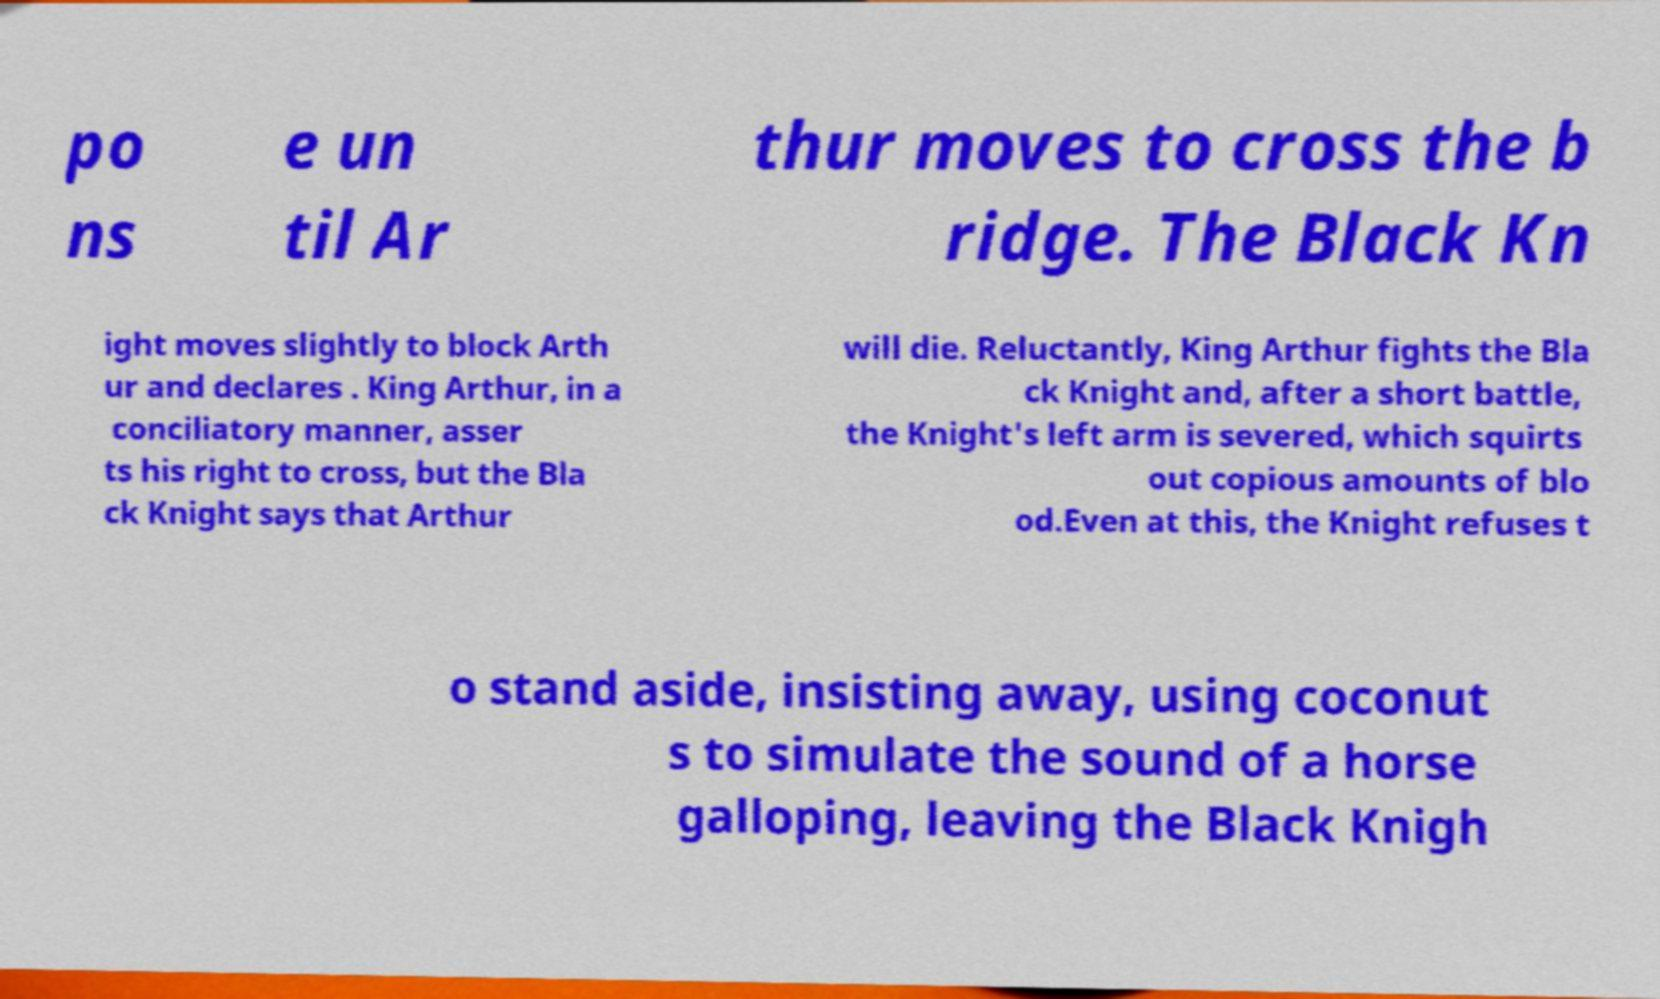Please read and relay the text visible in this image. What does it say? po ns e un til Ar thur moves to cross the b ridge. The Black Kn ight moves slightly to block Arth ur and declares . King Arthur, in a conciliatory manner, asser ts his right to cross, but the Bla ck Knight says that Arthur will die. Reluctantly, King Arthur fights the Bla ck Knight and, after a short battle, the Knight's left arm is severed, which squirts out copious amounts of blo od.Even at this, the Knight refuses t o stand aside, insisting away, using coconut s to simulate the sound of a horse galloping, leaving the Black Knigh 